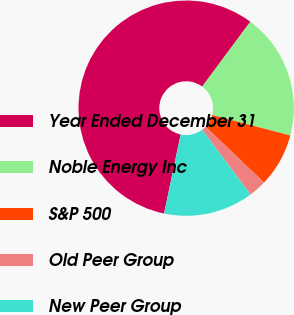<chart> <loc_0><loc_0><loc_500><loc_500><pie_chart><fcel>Year Ended December 31<fcel>Noble Energy Inc<fcel>S&P 500<fcel>Old Peer Group<fcel>New Peer Group<nl><fcel>56.88%<fcel>18.92%<fcel>8.07%<fcel>2.65%<fcel>13.49%<nl></chart> 